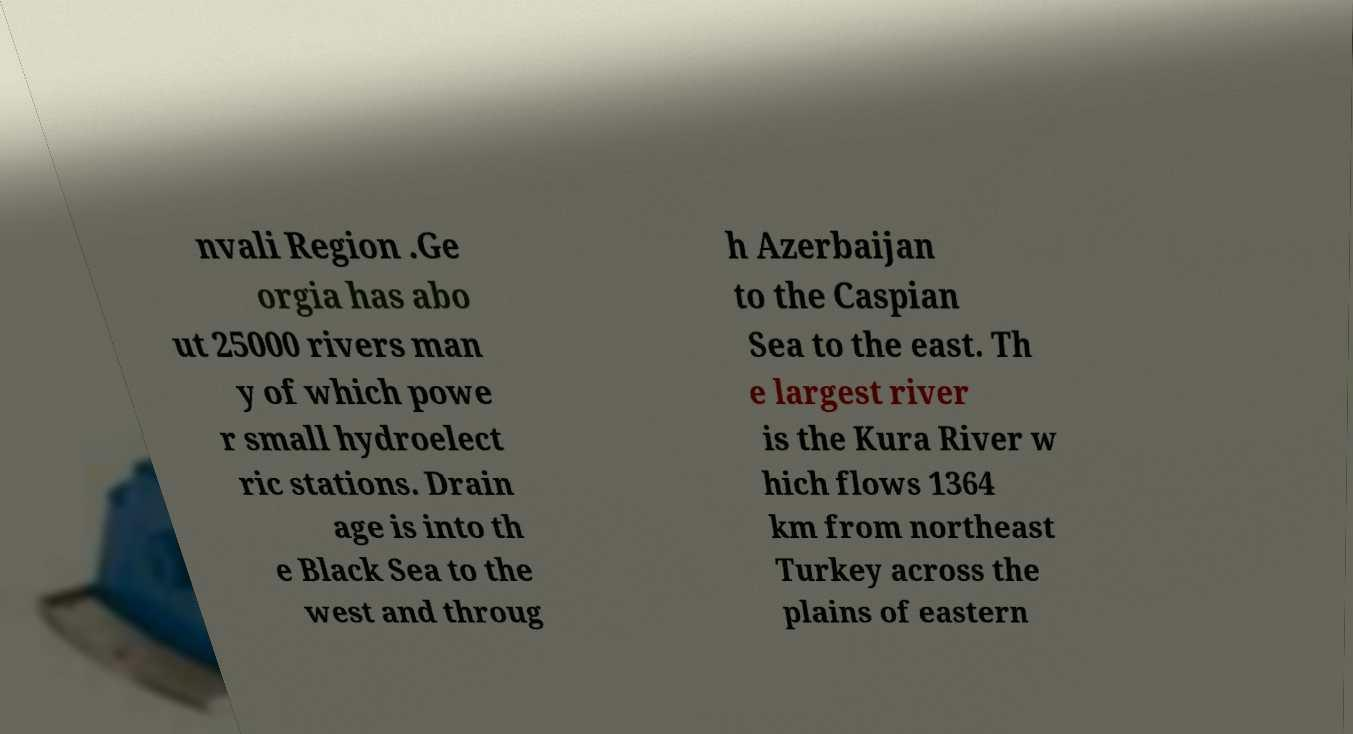Please read and relay the text visible in this image. What does it say? nvali Region .Ge orgia has abo ut 25000 rivers man y of which powe r small hydroelect ric stations. Drain age is into th e Black Sea to the west and throug h Azerbaijan to the Caspian Sea to the east. Th e largest river is the Kura River w hich flows 1364 km from northeast Turkey across the plains of eastern 